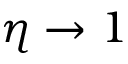<formula> <loc_0><loc_0><loc_500><loc_500>\eta \to 1</formula> 